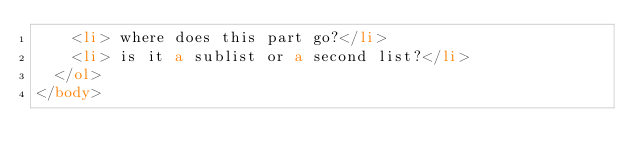<code> <loc_0><loc_0><loc_500><loc_500><_HTML_>    <li> where does this part go?</li>
    <li> is it a sublist or a second list?</li>
  </ol>
</body>
</code> 